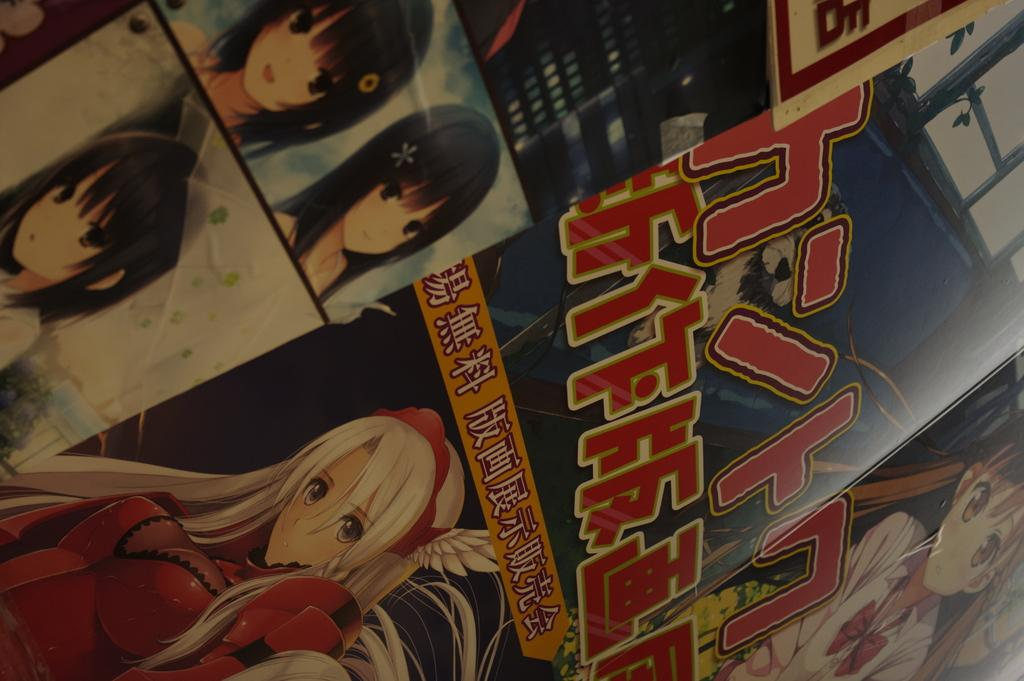What object is present in the image that is typically used for storage or packaging? There is a cardboard box in the image. What is written or printed on the cardboard box? There are words on the cardboard box. What type of design is featured on the cardboard box? There are cartoon characters on the cardboard box. What type of can is depicted on the cardboard box? There is no can present on the cardboard box; it features words and cartoon characters. How many cherries are visible on the cardboard box? There are no cherries present on the cardboard box. 